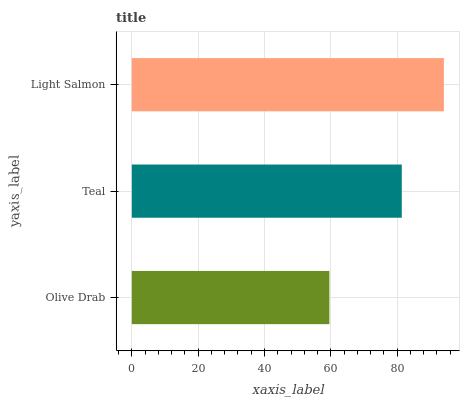Is Olive Drab the minimum?
Answer yes or no. Yes. Is Light Salmon the maximum?
Answer yes or no. Yes. Is Teal the minimum?
Answer yes or no. No. Is Teal the maximum?
Answer yes or no. No. Is Teal greater than Olive Drab?
Answer yes or no. Yes. Is Olive Drab less than Teal?
Answer yes or no. Yes. Is Olive Drab greater than Teal?
Answer yes or no. No. Is Teal less than Olive Drab?
Answer yes or no. No. Is Teal the high median?
Answer yes or no. Yes. Is Teal the low median?
Answer yes or no. Yes. Is Light Salmon the high median?
Answer yes or no. No. Is Olive Drab the low median?
Answer yes or no. No. 